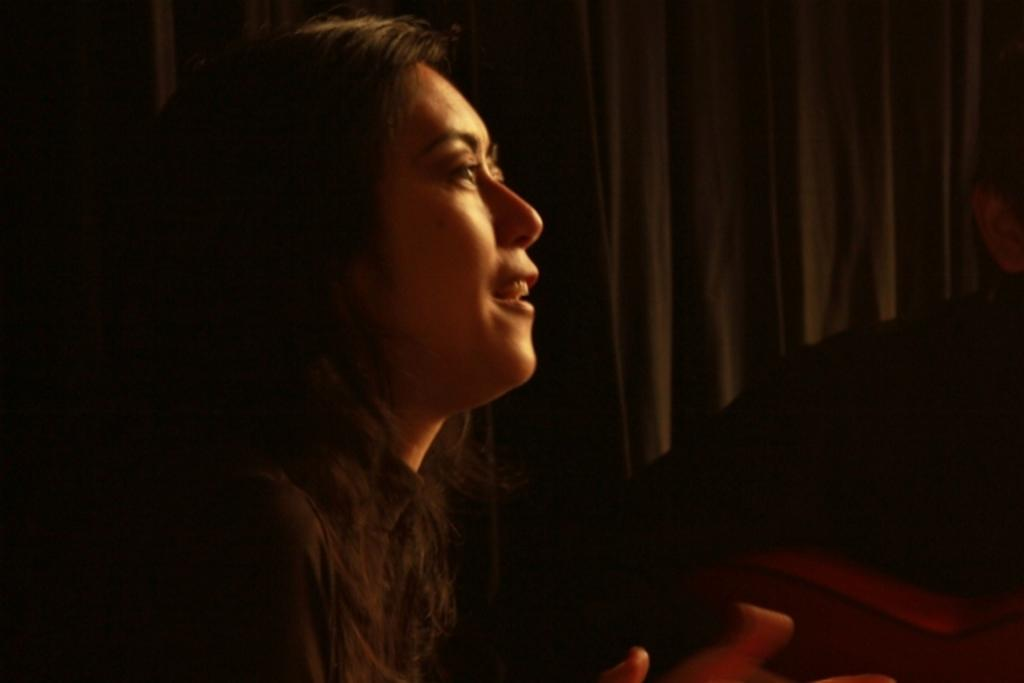Who is present in the image? There is a woman in the image. Can you describe the other person in the image? There is another person on the right side of the image. What can be seen in the background of the image? There is a black color curtain in the background of the image. What type of jewel is the woman wearing on her neck in the image? There is no jewel visible on the woman's neck in the image. Is there a soap dispenser present in the image? There is no soap dispenser present in the image. 